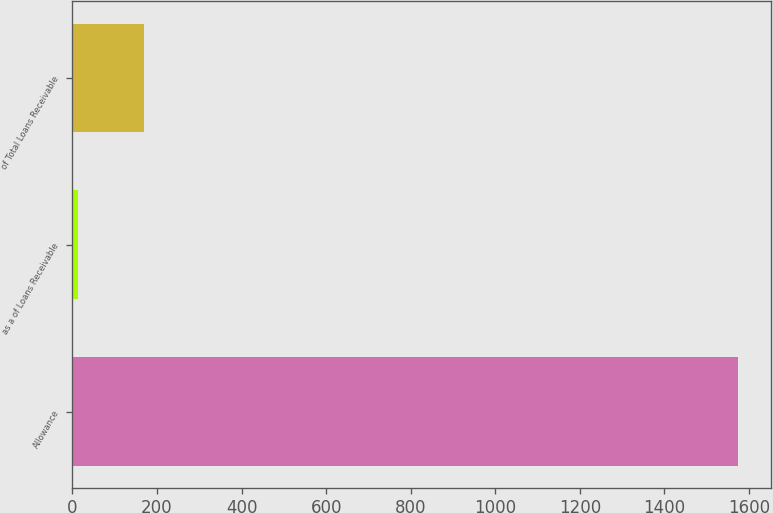Convert chart. <chart><loc_0><loc_0><loc_500><loc_500><bar_chart><fcel>Allowance<fcel>as a of Loans Receivable<fcel>of Total Loans Receivable<nl><fcel>1574<fcel>14<fcel>170<nl></chart> 